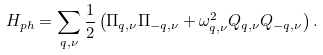<formula> <loc_0><loc_0><loc_500><loc_500>H _ { p h } = \sum _ { { q } , \nu } \frac { 1 } { 2 } \left ( \Pi _ { { q } , \nu } \Pi _ { - { q } , \nu } + \omega _ { { q } , \nu } ^ { 2 } Q _ { { q } , \nu } Q _ { - { q } , \nu } \right ) .</formula> 